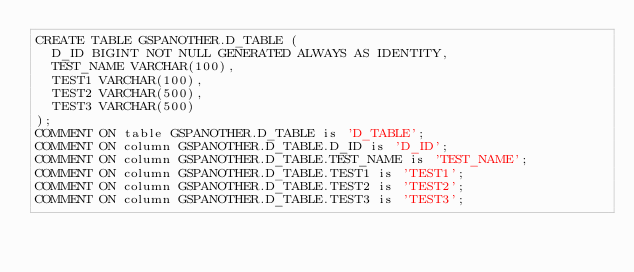<code> <loc_0><loc_0><loc_500><loc_500><_SQL_>CREATE TABLE GSPANOTHER.D_TABLE (
  D_ID BIGINT NOT NULL GENERATED ALWAYS AS IDENTITY,
  TEST_NAME VARCHAR(100),
  TEST1 VARCHAR(100),
  TEST2 VARCHAR(500),
  TEST3 VARCHAR(500)
);
COMMENT ON table GSPANOTHER.D_TABLE is 'D_TABLE';
COMMENT ON column GSPANOTHER.D_TABLE.D_ID is 'D_ID';
COMMENT ON column GSPANOTHER.D_TABLE.TEST_NAME is 'TEST_NAME';
COMMENT ON column GSPANOTHER.D_TABLE.TEST1 is 'TEST1';
COMMENT ON column GSPANOTHER.D_TABLE.TEST2 is 'TEST2';
COMMENT ON column GSPANOTHER.D_TABLE.TEST3 is 'TEST3';
</code> 